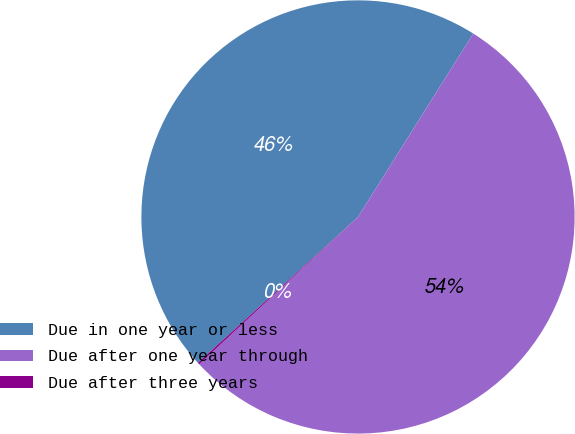Convert chart. <chart><loc_0><loc_0><loc_500><loc_500><pie_chart><fcel>Due in one year or less<fcel>Due after one year through<fcel>Due after three years<nl><fcel>45.69%<fcel>54.17%<fcel>0.14%<nl></chart> 